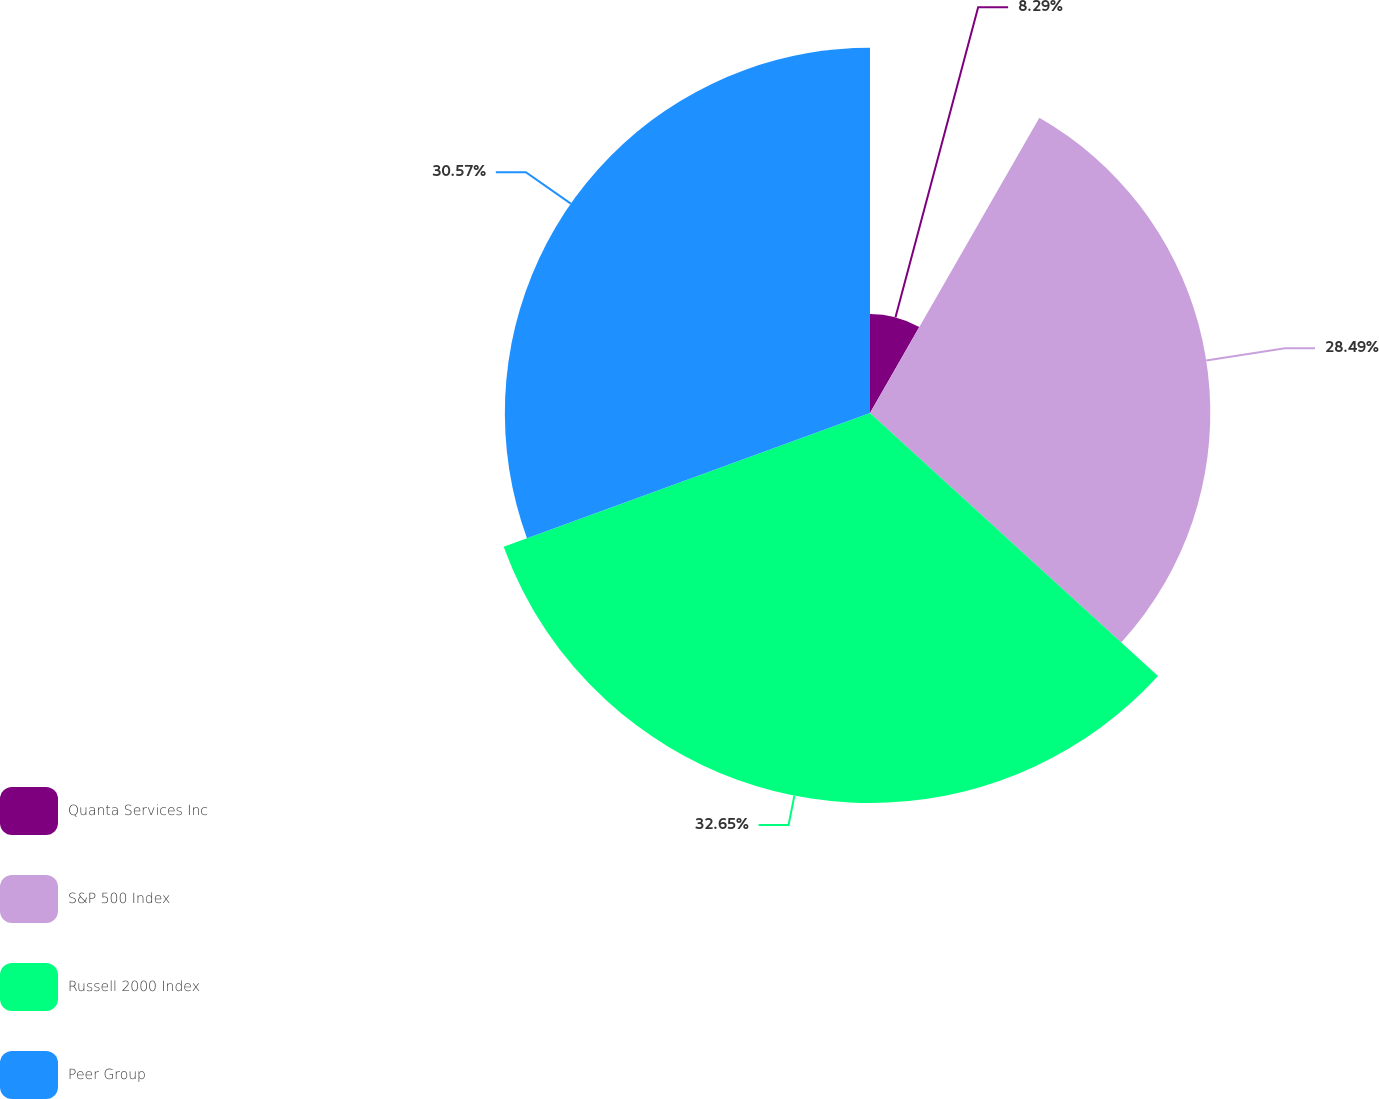Convert chart to OTSL. <chart><loc_0><loc_0><loc_500><loc_500><pie_chart><fcel>Quanta Services Inc<fcel>S&P 500 Index<fcel>Russell 2000 Index<fcel>Peer Group<nl><fcel>8.29%<fcel>28.49%<fcel>32.65%<fcel>30.57%<nl></chart> 